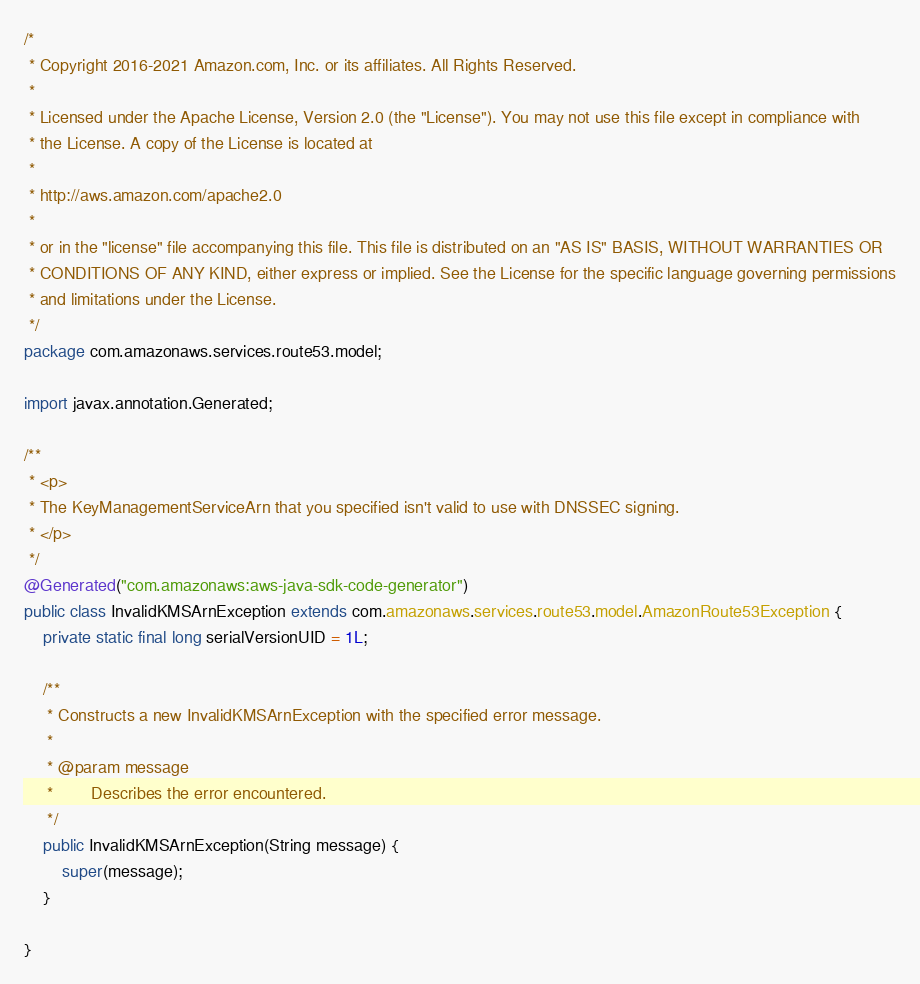Convert code to text. <code><loc_0><loc_0><loc_500><loc_500><_Java_>/*
 * Copyright 2016-2021 Amazon.com, Inc. or its affiliates. All Rights Reserved.
 * 
 * Licensed under the Apache License, Version 2.0 (the "License"). You may not use this file except in compliance with
 * the License. A copy of the License is located at
 * 
 * http://aws.amazon.com/apache2.0
 * 
 * or in the "license" file accompanying this file. This file is distributed on an "AS IS" BASIS, WITHOUT WARRANTIES OR
 * CONDITIONS OF ANY KIND, either express or implied. See the License for the specific language governing permissions
 * and limitations under the License.
 */
package com.amazonaws.services.route53.model;

import javax.annotation.Generated;

/**
 * <p>
 * The KeyManagementServiceArn that you specified isn't valid to use with DNSSEC signing.
 * </p>
 */
@Generated("com.amazonaws:aws-java-sdk-code-generator")
public class InvalidKMSArnException extends com.amazonaws.services.route53.model.AmazonRoute53Exception {
    private static final long serialVersionUID = 1L;

    /**
     * Constructs a new InvalidKMSArnException with the specified error message.
     *
     * @param message
     *        Describes the error encountered.
     */
    public InvalidKMSArnException(String message) {
        super(message);
    }

}
</code> 